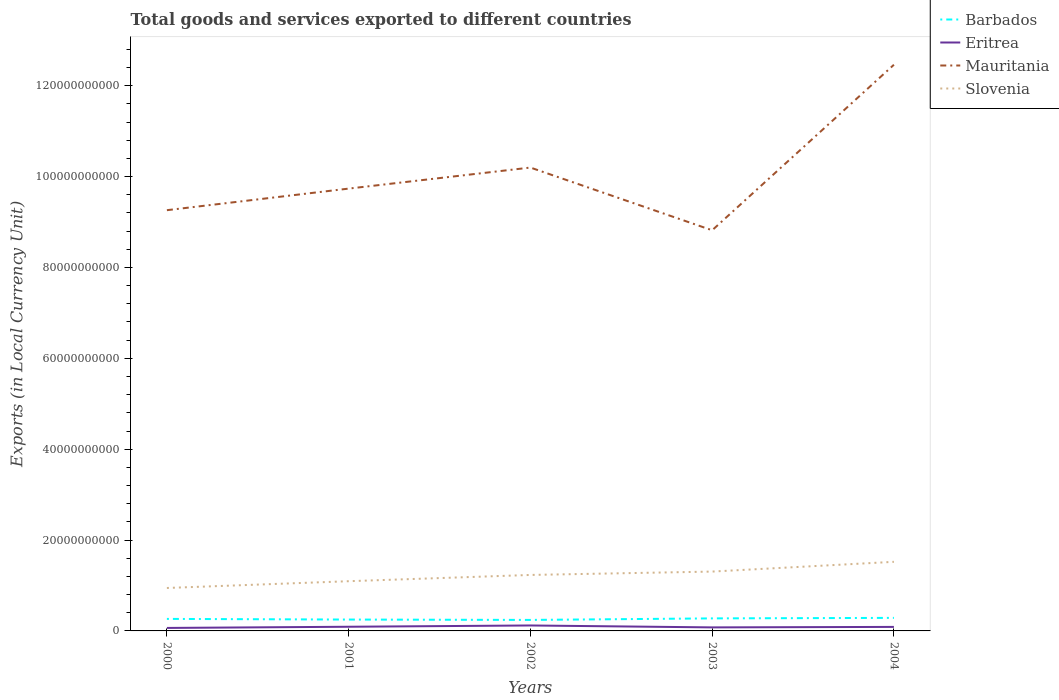Does the line corresponding to Slovenia intersect with the line corresponding to Eritrea?
Keep it short and to the point. No. Across all years, what is the maximum Amount of goods and services exports in Eritrea?
Your response must be concise. 6.57e+08. In which year was the Amount of goods and services exports in Eritrea maximum?
Your response must be concise. 2000. What is the total Amount of goods and services exports in Barbados in the graph?
Keep it short and to the point. -3.69e+08. What is the difference between the highest and the second highest Amount of goods and services exports in Eritrea?
Give a very brief answer. 5.42e+08. What is the difference between two consecutive major ticks on the Y-axis?
Give a very brief answer. 2.00e+1. Are the values on the major ticks of Y-axis written in scientific E-notation?
Provide a short and direct response. No. Does the graph contain any zero values?
Give a very brief answer. No. Does the graph contain grids?
Provide a succinct answer. No. Where does the legend appear in the graph?
Provide a short and direct response. Top right. How many legend labels are there?
Offer a very short reply. 4. What is the title of the graph?
Offer a very short reply. Total goods and services exported to different countries. What is the label or title of the X-axis?
Your response must be concise. Years. What is the label or title of the Y-axis?
Your response must be concise. Exports (in Local Currency Unit). What is the Exports (in Local Currency Unit) in Barbados in 2000?
Offer a terse response. 2.65e+09. What is the Exports (in Local Currency Unit) of Eritrea in 2000?
Make the answer very short. 6.57e+08. What is the Exports (in Local Currency Unit) in Mauritania in 2000?
Your answer should be very brief. 9.26e+1. What is the Exports (in Local Currency Unit) in Slovenia in 2000?
Make the answer very short. 9.45e+09. What is the Exports (in Local Currency Unit) in Barbados in 2001?
Your answer should be very brief. 2.50e+09. What is the Exports (in Local Currency Unit) of Eritrea in 2001?
Ensure brevity in your answer.  9.20e+08. What is the Exports (in Local Currency Unit) of Mauritania in 2001?
Your answer should be very brief. 9.74e+1. What is the Exports (in Local Currency Unit) in Slovenia in 2001?
Your response must be concise. 1.09e+1. What is the Exports (in Local Currency Unit) in Barbados in 2002?
Give a very brief answer. 2.42e+09. What is the Exports (in Local Currency Unit) of Eritrea in 2002?
Provide a short and direct response. 1.20e+09. What is the Exports (in Local Currency Unit) of Mauritania in 2002?
Give a very brief answer. 1.02e+11. What is the Exports (in Local Currency Unit) in Slovenia in 2002?
Provide a short and direct response. 1.23e+1. What is the Exports (in Local Currency Unit) of Barbados in 2003?
Offer a very short reply. 2.76e+09. What is the Exports (in Local Currency Unit) in Eritrea in 2003?
Offer a terse response. 7.78e+08. What is the Exports (in Local Currency Unit) in Mauritania in 2003?
Keep it short and to the point. 8.82e+1. What is the Exports (in Local Currency Unit) in Slovenia in 2003?
Your answer should be compact. 1.31e+1. What is the Exports (in Local Currency Unit) of Barbados in 2004?
Your response must be concise. 2.87e+09. What is the Exports (in Local Currency Unit) of Eritrea in 2004?
Make the answer very short. 8.83e+08. What is the Exports (in Local Currency Unit) of Mauritania in 2004?
Ensure brevity in your answer.  1.25e+11. What is the Exports (in Local Currency Unit) in Slovenia in 2004?
Give a very brief answer. 1.52e+1. Across all years, what is the maximum Exports (in Local Currency Unit) of Barbados?
Give a very brief answer. 2.87e+09. Across all years, what is the maximum Exports (in Local Currency Unit) in Eritrea?
Ensure brevity in your answer.  1.20e+09. Across all years, what is the maximum Exports (in Local Currency Unit) in Mauritania?
Give a very brief answer. 1.25e+11. Across all years, what is the maximum Exports (in Local Currency Unit) of Slovenia?
Make the answer very short. 1.52e+1. Across all years, what is the minimum Exports (in Local Currency Unit) of Barbados?
Your answer should be compact. 2.42e+09. Across all years, what is the minimum Exports (in Local Currency Unit) of Eritrea?
Keep it short and to the point. 6.57e+08. Across all years, what is the minimum Exports (in Local Currency Unit) in Mauritania?
Ensure brevity in your answer.  8.82e+1. Across all years, what is the minimum Exports (in Local Currency Unit) of Slovenia?
Give a very brief answer. 9.45e+09. What is the total Exports (in Local Currency Unit) in Barbados in the graph?
Keep it short and to the point. 1.32e+1. What is the total Exports (in Local Currency Unit) of Eritrea in the graph?
Keep it short and to the point. 4.44e+09. What is the total Exports (in Local Currency Unit) in Mauritania in the graph?
Provide a short and direct response. 5.05e+11. What is the total Exports (in Local Currency Unit) of Slovenia in the graph?
Provide a succinct answer. 6.10e+1. What is the difference between the Exports (in Local Currency Unit) in Barbados in 2000 and that in 2001?
Provide a short and direct response. 1.43e+08. What is the difference between the Exports (in Local Currency Unit) of Eritrea in 2000 and that in 2001?
Offer a very short reply. -2.62e+08. What is the difference between the Exports (in Local Currency Unit) in Mauritania in 2000 and that in 2001?
Provide a short and direct response. -4.75e+09. What is the difference between the Exports (in Local Currency Unit) of Slovenia in 2000 and that in 2001?
Provide a short and direct response. -1.49e+09. What is the difference between the Exports (in Local Currency Unit) in Barbados in 2000 and that in 2002?
Provide a short and direct response. 2.24e+08. What is the difference between the Exports (in Local Currency Unit) of Eritrea in 2000 and that in 2002?
Keep it short and to the point. -5.42e+08. What is the difference between the Exports (in Local Currency Unit) in Mauritania in 2000 and that in 2002?
Provide a succinct answer. -9.38e+09. What is the difference between the Exports (in Local Currency Unit) of Slovenia in 2000 and that in 2002?
Ensure brevity in your answer.  -2.87e+09. What is the difference between the Exports (in Local Currency Unit) in Barbados in 2000 and that in 2003?
Offer a terse response. -1.12e+08. What is the difference between the Exports (in Local Currency Unit) of Eritrea in 2000 and that in 2003?
Make the answer very short. -1.21e+08. What is the difference between the Exports (in Local Currency Unit) of Mauritania in 2000 and that in 2003?
Your response must be concise. 4.42e+09. What is the difference between the Exports (in Local Currency Unit) in Slovenia in 2000 and that in 2003?
Give a very brief answer. -3.61e+09. What is the difference between the Exports (in Local Currency Unit) in Barbados in 2000 and that in 2004?
Your answer should be very brief. -2.26e+08. What is the difference between the Exports (in Local Currency Unit) of Eritrea in 2000 and that in 2004?
Ensure brevity in your answer.  -2.26e+08. What is the difference between the Exports (in Local Currency Unit) of Mauritania in 2000 and that in 2004?
Provide a short and direct response. -3.20e+1. What is the difference between the Exports (in Local Currency Unit) in Slovenia in 2000 and that in 2004?
Give a very brief answer. -5.76e+09. What is the difference between the Exports (in Local Currency Unit) in Barbados in 2001 and that in 2002?
Your answer should be compact. 8.10e+07. What is the difference between the Exports (in Local Currency Unit) of Eritrea in 2001 and that in 2002?
Give a very brief answer. -2.80e+08. What is the difference between the Exports (in Local Currency Unit) of Mauritania in 2001 and that in 2002?
Ensure brevity in your answer.  -4.63e+09. What is the difference between the Exports (in Local Currency Unit) in Slovenia in 2001 and that in 2002?
Your response must be concise. -1.38e+09. What is the difference between the Exports (in Local Currency Unit) in Barbados in 2001 and that in 2003?
Give a very brief answer. -2.55e+08. What is the difference between the Exports (in Local Currency Unit) in Eritrea in 2001 and that in 2003?
Make the answer very short. 1.42e+08. What is the difference between the Exports (in Local Currency Unit) in Mauritania in 2001 and that in 2003?
Your answer should be compact. 9.17e+09. What is the difference between the Exports (in Local Currency Unit) in Slovenia in 2001 and that in 2003?
Give a very brief answer. -2.12e+09. What is the difference between the Exports (in Local Currency Unit) in Barbados in 2001 and that in 2004?
Give a very brief answer. -3.69e+08. What is the difference between the Exports (in Local Currency Unit) in Eritrea in 2001 and that in 2004?
Your answer should be very brief. 3.64e+07. What is the difference between the Exports (in Local Currency Unit) in Mauritania in 2001 and that in 2004?
Your response must be concise. -2.73e+1. What is the difference between the Exports (in Local Currency Unit) of Slovenia in 2001 and that in 2004?
Offer a terse response. -4.27e+09. What is the difference between the Exports (in Local Currency Unit) in Barbados in 2002 and that in 2003?
Offer a very short reply. -3.36e+08. What is the difference between the Exports (in Local Currency Unit) in Eritrea in 2002 and that in 2003?
Keep it short and to the point. 4.21e+08. What is the difference between the Exports (in Local Currency Unit) of Mauritania in 2002 and that in 2003?
Offer a very short reply. 1.38e+1. What is the difference between the Exports (in Local Currency Unit) in Slovenia in 2002 and that in 2003?
Make the answer very short. -7.43e+08. What is the difference between the Exports (in Local Currency Unit) in Barbados in 2002 and that in 2004?
Ensure brevity in your answer.  -4.50e+08. What is the difference between the Exports (in Local Currency Unit) of Eritrea in 2002 and that in 2004?
Keep it short and to the point. 3.16e+08. What is the difference between the Exports (in Local Currency Unit) of Mauritania in 2002 and that in 2004?
Your response must be concise. -2.26e+1. What is the difference between the Exports (in Local Currency Unit) in Slovenia in 2002 and that in 2004?
Your answer should be compact. -2.89e+09. What is the difference between the Exports (in Local Currency Unit) of Barbados in 2003 and that in 2004?
Your answer should be very brief. -1.14e+08. What is the difference between the Exports (in Local Currency Unit) of Eritrea in 2003 and that in 2004?
Your response must be concise. -1.05e+08. What is the difference between the Exports (in Local Currency Unit) of Mauritania in 2003 and that in 2004?
Offer a terse response. -3.64e+1. What is the difference between the Exports (in Local Currency Unit) of Slovenia in 2003 and that in 2004?
Your answer should be compact. -2.15e+09. What is the difference between the Exports (in Local Currency Unit) of Barbados in 2000 and the Exports (in Local Currency Unit) of Eritrea in 2001?
Provide a short and direct response. 1.73e+09. What is the difference between the Exports (in Local Currency Unit) of Barbados in 2000 and the Exports (in Local Currency Unit) of Mauritania in 2001?
Provide a succinct answer. -9.47e+1. What is the difference between the Exports (in Local Currency Unit) in Barbados in 2000 and the Exports (in Local Currency Unit) in Slovenia in 2001?
Offer a very short reply. -8.30e+09. What is the difference between the Exports (in Local Currency Unit) in Eritrea in 2000 and the Exports (in Local Currency Unit) in Mauritania in 2001?
Offer a terse response. -9.67e+1. What is the difference between the Exports (in Local Currency Unit) in Eritrea in 2000 and the Exports (in Local Currency Unit) in Slovenia in 2001?
Your answer should be very brief. -1.03e+1. What is the difference between the Exports (in Local Currency Unit) in Mauritania in 2000 and the Exports (in Local Currency Unit) in Slovenia in 2001?
Offer a very short reply. 8.17e+1. What is the difference between the Exports (in Local Currency Unit) in Barbados in 2000 and the Exports (in Local Currency Unit) in Eritrea in 2002?
Keep it short and to the point. 1.45e+09. What is the difference between the Exports (in Local Currency Unit) in Barbados in 2000 and the Exports (in Local Currency Unit) in Mauritania in 2002?
Offer a very short reply. -9.93e+1. What is the difference between the Exports (in Local Currency Unit) of Barbados in 2000 and the Exports (in Local Currency Unit) of Slovenia in 2002?
Your answer should be very brief. -9.67e+09. What is the difference between the Exports (in Local Currency Unit) in Eritrea in 2000 and the Exports (in Local Currency Unit) in Mauritania in 2002?
Provide a short and direct response. -1.01e+11. What is the difference between the Exports (in Local Currency Unit) in Eritrea in 2000 and the Exports (in Local Currency Unit) in Slovenia in 2002?
Your response must be concise. -1.17e+1. What is the difference between the Exports (in Local Currency Unit) of Mauritania in 2000 and the Exports (in Local Currency Unit) of Slovenia in 2002?
Ensure brevity in your answer.  8.03e+1. What is the difference between the Exports (in Local Currency Unit) of Barbados in 2000 and the Exports (in Local Currency Unit) of Eritrea in 2003?
Provide a succinct answer. 1.87e+09. What is the difference between the Exports (in Local Currency Unit) in Barbados in 2000 and the Exports (in Local Currency Unit) in Mauritania in 2003?
Provide a short and direct response. -8.55e+1. What is the difference between the Exports (in Local Currency Unit) of Barbados in 2000 and the Exports (in Local Currency Unit) of Slovenia in 2003?
Offer a terse response. -1.04e+1. What is the difference between the Exports (in Local Currency Unit) in Eritrea in 2000 and the Exports (in Local Currency Unit) in Mauritania in 2003?
Offer a terse response. -8.75e+1. What is the difference between the Exports (in Local Currency Unit) in Eritrea in 2000 and the Exports (in Local Currency Unit) in Slovenia in 2003?
Make the answer very short. -1.24e+1. What is the difference between the Exports (in Local Currency Unit) of Mauritania in 2000 and the Exports (in Local Currency Unit) of Slovenia in 2003?
Give a very brief answer. 7.95e+1. What is the difference between the Exports (in Local Currency Unit) of Barbados in 2000 and the Exports (in Local Currency Unit) of Eritrea in 2004?
Provide a short and direct response. 1.76e+09. What is the difference between the Exports (in Local Currency Unit) of Barbados in 2000 and the Exports (in Local Currency Unit) of Mauritania in 2004?
Ensure brevity in your answer.  -1.22e+11. What is the difference between the Exports (in Local Currency Unit) of Barbados in 2000 and the Exports (in Local Currency Unit) of Slovenia in 2004?
Provide a short and direct response. -1.26e+1. What is the difference between the Exports (in Local Currency Unit) of Eritrea in 2000 and the Exports (in Local Currency Unit) of Mauritania in 2004?
Keep it short and to the point. -1.24e+11. What is the difference between the Exports (in Local Currency Unit) in Eritrea in 2000 and the Exports (in Local Currency Unit) in Slovenia in 2004?
Keep it short and to the point. -1.46e+1. What is the difference between the Exports (in Local Currency Unit) in Mauritania in 2000 and the Exports (in Local Currency Unit) in Slovenia in 2004?
Your answer should be compact. 7.74e+1. What is the difference between the Exports (in Local Currency Unit) in Barbados in 2001 and the Exports (in Local Currency Unit) in Eritrea in 2002?
Provide a succinct answer. 1.30e+09. What is the difference between the Exports (in Local Currency Unit) in Barbados in 2001 and the Exports (in Local Currency Unit) in Mauritania in 2002?
Your answer should be compact. -9.95e+1. What is the difference between the Exports (in Local Currency Unit) in Barbados in 2001 and the Exports (in Local Currency Unit) in Slovenia in 2002?
Make the answer very short. -9.82e+09. What is the difference between the Exports (in Local Currency Unit) in Eritrea in 2001 and the Exports (in Local Currency Unit) in Mauritania in 2002?
Make the answer very short. -1.01e+11. What is the difference between the Exports (in Local Currency Unit) of Eritrea in 2001 and the Exports (in Local Currency Unit) of Slovenia in 2002?
Your response must be concise. -1.14e+1. What is the difference between the Exports (in Local Currency Unit) of Mauritania in 2001 and the Exports (in Local Currency Unit) of Slovenia in 2002?
Provide a short and direct response. 8.50e+1. What is the difference between the Exports (in Local Currency Unit) of Barbados in 2001 and the Exports (in Local Currency Unit) of Eritrea in 2003?
Your response must be concise. 1.72e+09. What is the difference between the Exports (in Local Currency Unit) of Barbados in 2001 and the Exports (in Local Currency Unit) of Mauritania in 2003?
Provide a short and direct response. -8.57e+1. What is the difference between the Exports (in Local Currency Unit) in Barbados in 2001 and the Exports (in Local Currency Unit) in Slovenia in 2003?
Offer a terse response. -1.06e+1. What is the difference between the Exports (in Local Currency Unit) in Eritrea in 2001 and the Exports (in Local Currency Unit) in Mauritania in 2003?
Provide a succinct answer. -8.73e+1. What is the difference between the Exports (in Local Currency Unit) of Eritrea in 2001 and the Exports (in Local Currency Unit) of Slovenia in 2003?
Your answer should be very brief. -1.21e+1. What is the difference between the Exports (in Local Currency Unit) in Mauritania in 2001 and the Exports (in Local Currency Unit) in Slovenia in 2003?
Ensure brevity in your answer.  8.43e+1. What is the difference between the Exports (in Local Currency Unit) of Barbados in 2001 and the Exports (in Local Currency Unit) of Eritrea in 2004?
Give a very brief answer. 1.62e+09. What is the difference between the Exports (in Local Currency Unit) in Barbados in 2001 and the Exports (in Local Currency Unit) in Mauritania in 2004?
Make the answer very short. -1.22e+11. What is the difference between the Exports (in Local Currency Unit) of Barbados in 2001 and the Exports (in Local Currency Unit) of Slovenia in 2004?
Make the answer very short. -1.27e+1. What is the difference between the Exports (in Local Currency Unit) of Eritrea in 2001 and the Exports (in Local Currency Unit) of Mauritania in 2004?
Offer a terse response. -1.24e+11. What is the difference between the Exports (in Local Currency Unit) of Eritrea in 2001 and the Exports (in Local Currency Unit) of Slovenia in 2004?
Give a very brief answer. -1.43e+1. What is the difference between the Exports (in Local Currency Unit) in Mauritania in 2001 and the Exports (in Local Currency Unit) in Slovenia in 2004?
Provide a succinct answer. 8.21e+1. What is the difference between the Exports (in Local Currency Unit) in Barbados in 2002 and the Exports (in Local Currency Unit) in Eritrea in 2003?
Offer a very short reply. 1.64e+09. What is the difference between the Exports (in Local Currency Unit) of Barbados in 2002 and the Exports (in Local Currency Unit) of Mauritania in 2003?
Your answer should be compact. -8.58e+1. What is the difference between the Exports (in Local Currency Unit) in Barbados in 2002 and the Exports (in Local Currency Unit) in Slovenia in 2003?
Your answer should be compact. -1.06e+1. What is the difference between the Exports (in Local Currency Unit) of Eritrea in 2002 and the Exports (in Local Currency Unit) of Mauritania in 2003?
Your answer should be compact. -8.70e+1. What is the difference between the Exports (in Local Currency Unit) in Eritrea in 2002 and the Exports (in Local Currency Unit) in Slovenia in 2003?
Make the answer very short. -1.19e+1. What is the difference between the Exports (in Local Currency Unit) in Mauritania in 2002 and the Exports (in Local Currency Unit) in Slovenia in 2003?
Offer a very short reply. 8.89e+1. What is the difference between the Exports (in Local Currency Unit) in Barbados in 2002 and the Exports (in Local Currency Unit) in Eritrea in 2004?
Your answer should be very brief. 1.54e+09. What is the difference between the Exports (in Local Currency Unit) in Barbados in 2002 and the Exports (in Local Currency Unit) in Mauritania in 2004?
Provide a succinct answer. -1.22e+11. What is the difference between the Exports (in Local Currency Unit) of Barbados in 2002 and the Exports (in Local Currency Unit) of Slovenia in 2004?
Offer a terse response. -1.28e+1. What is the difference between the Exports (in Local Currency Unit) in Eritrea in 2002 and the Exports (in Local Currency Unit) in Mauritania in 2004?
Provide a succinct answer. -1.23e+11. What is the difference between the Exports (in Local Currency Unit) in Eritrea in 2002 and the Exports (in Local Currency Unit) in Slovenia in 2004?
Your response must be concise. -1.40e+1. What is the difference between the Exports (in Local Currency Unit) of Mauritania in 2002 and the Exports (in Local Currency Unit) of Slovenia in 2004?
Offer a terse response. 8.68e+1. What is the difference between the Exports (in Local Currency Unit) of Barbados in 2003 and the Exports (in Local Currency Unit) of Eritrea in 2004?
Your answer should be very brief. 1.87e+09. What is the difference between the Exports (in Local Currency Unit) of Barbados in 2003 and the Exports (in Local Currency Unit) of Mauritania in 2004?
Ensure brevity in your answer.  -1.22e+11. What is the difference between the Exports (in Local Currency Unit) of Barbados in 2003 and the Exports (in Local Currency Unit) of Slovenia in 2004?
Give a very brief answer. -1.25e+1. What is the difference between the Exports (in Local Currency Unit) of Eritrea in 2003 and the Exports (in Local Currency Unit) of Mauritania in 2004?
Your response must be concise. -1.24e+11. What is the difference between the Exports (in Local Currency Unit) of Eritrea in 2003 and the Exports (in Local Currency Unit) of Slovenia in 2004?
Your response must be concise. -1.44e+1. What is the difference between the Exports (in Local Currency Unit) in Mauritania in 2003 and the Exports (in Local Currency Unit) in Slovenia in 2004?
Give a very brief answer. 7.30e+1. What is the average Exports (in Local Currency Unit) of Barbados per year?
Keep it short and to the point. 2.64e+09. What is the average Exports (in Local Currency Unit) in Eritrea per year?
Give a very brief answer. 8.88e+08. What is the average Exports (in Local Currency Unit) of Mauritania per year?
Your answer should be compact. 1.01e+11. What is the average Exports (in Local Currency Unit) of Slovenia per year?
Provide a succinct answer. 1.22e+1. In the year 2000, what is the difference between the Exports (in Local Currency Unit) of Barbados and Exports (in Local Currency Unit) of Eritrea?
Offer a terse response. 1.99e+09. In the year 2000, what is the difference between the Exports (in Local Currency Unit) in Barbados and Exports (in Local Currency Unit) in Mauritania?
Offer a very short reply. -9.00e+1. In the year 2000, what is the difference between the Exports (in Local Currency Unit) in Barbados and Exports (in Local Currency Unit) in Slovenia?
Make the answer very short. -6.81e+09. In the year 2000, what is the difference between the Exports (in Local Currency Unit) of Eritrea and Exports (in Local Currency Unit) of Mauritania?
Your answer should be very brief. -9.19e+1. In the year 2000, what is the difference between the Exports (in Local Currency Unit) in Eritrea and Exports (in Local Currency Unit) in Slovenia?
Keep it short and to the point. -8.79e+09. In the year 2000, what is the difference between the Exports (in Local Currency Unit) in Mauritania and Exports (in Local Currency Unit) in Slovenia?
Make the answer very short. 8.32e+1. In the year 2001, what is the difference between the Exports (in Local Currency Unit) of Barbados and Exports (in Local Currency Unit) of Eritrea?
Keep it short and to the point. 1.58e+09. In the year 2001, what is the difference between the Exports (in Local Currency Unit) in Barbados and Exports (in Local Currency Unit) in Mauritania?
Your answer should be compact. -9.49e+1. In the year 2001, what is the difference between the Exports (in Local Currency Unit) of Barbados and Exports (in Local Currency Unit) of Slovenia?
Keep it short and to the point. -8.44e+09. In the year 2001, what is the difference between the Exports (in Local Currency Unit) in Eritrea and Exports (in Local Currency Unit) in Mauritania?
Provide a succinct answer. -9.64e+1. In the year 2001, what is the difference between the Exports (in Local Currency Unit) in Eritrea and Exports (in Local Currency Unit) in Slovenia?
Make the answer very short. -1.00e+1. In the year 2001, what is the difference between the Exports (in Local Currency Unit) of Mauritania and Exports (in Local Currency Unit) of Slovenia?
Offer a terse response. 8.64e+1. In the year 2002, what is the difference between the Exports (in Local Currency Unit) of Barbados and Exports (in Local Currency Unit) of Eritrea?
Your answer should be compact. 1.22e+09. In the year 2002, what is the difference between the Exports (in Local Currency Unit) of Barbados and Exports (in Local Currency Unit) of Mauritania?
Make the answer very short. -9.96e+1. In the year 2002, what is the difference between the Exports (in Local Currency Unit) in Barbados and Exports (in Local Currency Unit) in Slovenia?
Give a very brief answer. -9.90e+09. In the year 2002, what is the difference between the Exports (in Local Currency Unit) of Eritrea and Exports (in Local Currency Unit) of Mauritania?
Your answer should be compact. -1.01e+11. In the year 2002, what is the difference between the Exports (in Local Currency Unit) in Eritrea and Exports (in Local Currency Unit) in Slovenia?
Offer a very short reply. -1.11e+1. In the year 2002, what is the difference between the Exports (in Local Currency Unit) in Mauritania and Exports (in Local Currency Unit) in Slovenia?
Ensure brevity in your answer.  8.97e+1. In the year 2003, what is the difference between the Exports (in Local Currency Unit) of Barbados and Exports (in Local Currency Unit) of Eritrea?
Make the answer very short. 1.98e+09. In the year 2003, what is the difference between the Exports (in Local Currency Unit) of Barbados and Exports (in Local Currency Unit) of Mauritania?
Provide a short and direct response. -8.54e+1. In the year 2003, what is the difference between the Exports (in Local Currency Unit) in Barbados and Exports (in Local Currency Unit) in Slovenia?
Keep it short and to the point. -1.03e+1. In the year 2003, what is the difference between the Exports (in Local Currency Unit) in Eritrea and Exports (in Local Currency Unit) in Mauritania?
Make the answer very short. -8.74e+1. In the year 2003, what is the difference between the Exports (in Local Currency Unit) in Eritrea and Exports (in Local Currency Unit) in Slovenia?
Offer a very short reply. -1.23e+1. In the year 2003, what is the difference between the Exports (in Local Currency Unit) in Mauritania and Exports (in Local Currency Unit) in Slovenia?
Keep it short and to the point. 7.51e+1. In the year 2004, what is the difference between the Exports (in Local Currency Unit) in Barbados and Exports (in Local Currency Unit) in Eritrea?
Keep it short and to the point. 1.99e+09. In the year 2004, what is the difference between the Exports (in Local Currency Unit) in Barbados and Exports (in Local Currency Unit) in Mauritania?
Your response must be concise. -1.22e+11. In the year 2004, what is the difference between the Exports (in Local Currency Unit) in Barbados and Exports (in Local Currency Unit) in Slovenia?
Provide a short and direct response. -1.23e+1. In the year 2004, what is the difference between the Exports (in Local Currency Unit) of Eritrea and Exports (in Local Currency Unit) of Mauritania?
Your response must be concise. -1.24e+11. In the year 2004, what is the difference between the Exports (in Local Currency Unit) of Eritrea and Exports (in Local Currency Unit) of Slovenia?
Your answer should be compact. -1.43e+1. In the year 2004, what is the difference between the Exports (in Local Currency Unit) of Mauritania and Exports (in Local Currency Unit) of Slovenia?
Keep it short and to the point. 1.09e+11. What is the ratio of the Exports (in Local Currency Unit) in Barbados in 2000 to that in 2001?
Provide a short and direct response. 1.06. What is the ratio of the Exports (in Local Currency Unit) of Eritrea in 2000 to that in 2001?
Provide a succinct answer. 0.71. What is the ratio of the Exports (in Local Currency Unit) in Mauritania in 2000 to that in 2001?
Your answer should be very brief. 0.95. What is the ratio of the Exports (in Local Currency Unit) in Slovenia in 2000 to that in 2001?
Your answer should be compact. 0.86. What is the ratio of the Exports (in Local Currency Unit) in Barbados in 2000 to that in 2002?
Your answer should be very brief. 1.09. What is the ratio of the Exports (in Local Currency Unit) in Eritrea in 2000 to that in 2002?
Offer a very short reply. 0.55. What is the ratio of the Exports (in Local Currency Unit) of Mauritania in 2000 to that in 2002?
Ensure brevity in your answer.  0.91. What is the ratio of the Exports (in Local Currency Unit) in Slovenia in 2000 to that in 2002?
Provide a succinct answer. 0.77. What is the ratio of the Exports (in Local Currency Unit) in Barbados in 2000 to that in 2003?
Make the answer very short. 0.96. What is the ratio of the Exports (in Local Currency Unit) of Eritrea in 2000 to that in 2003?
Offer a terse response. 0.84. What is the ratio of the Exports (in Local Currency Unit) in Mauritania in 2000 to that in 2003?
Offer a very short reply. 1.05. What is the ratio of the Exports (in Local Currency Unit) in Slovenia in 2000 to that in 2003?
Offer a terse response. 0.72. What is the ratio of the Exports (in Local Currency Unit) of Barbados in 2000 to that in 2004?
Your answer should be very brief. 0.92. What is the ratio of the Exports (in Local Currency Unit) in Eritrea in 2000 to that in 2004?
Your answer should be compact. 0.74. What is the ratio of the Exports (in Local Currency Unit) of Mauritania in 2000 to that in 2004?
Provide a short and direct response. 0.74. What is the ratio of the Exports (in Local Currency Unit) of Slovenia in 2000 to that in 2004?
Your answer should be compact. 0.62. What is the ratio of the Exports (in Local Currency Unit) of Barbados in 2001 to that in 2002?
Your response must be concise. 1.03. What is the ratio of the Exports (in Local Currency Unit) of Eritrea in 2001 to that in 2002?
Give a very brief answer. 0.77. What is the ratio of the Exports (in Local Currency Unit) in Mauritania in 2001 to that in 2002?
Make the answer very short. 0.95. What is the ratio of the Exports (in Local Currency Unit) of Slovenia in 2001 to that in 2002?
Your answer should be very brief. 0.89. What is the ratio of the Exports (in Local Currency Unit) of Barbados in 2001 to that in 2003?
Make the answer very short. 0.91. What is the ratio of the Exports (in Local Currency Unit) of Eritrea in 2001 to that in 2003?
Your answer should be very brief. 1.18. What is the ratio of the Exports (in Local Currency Unit) of Mauritania in 2001 to that in 2003?
Ensure brevity in your answer.  1.1. What is the ratio of the Exports (in Local Currency Unit) in Slovenia in 2001 to that in 2003?
Your answer should be very brief. 0.84. What is the ratio of the Exports (in Local Currency Unit) of Barbados in 2001 to that in 2004?
Your response must be concise. 0.87. What is the ratio of the Exports (in Local Currency Unit) of Eritrea in 2001 to that in 2004?
Offer a terse response. 1.04. What is the ratio of the Exports (in Local Currency Unit) of Mauritania in 2001 to that in 2004?
Provide a succinct answer. 0.78. What is the ratio of the Exports (in Local Currency Unit) of Slovenia in 2001 to that in 2004?
Provide a succinct answer. 0.72. What is the ratio of the Exports (in Local Currency Unit) of Barbados in 2002 to that in 2003?
Make the answer very short. 0.88. What is the ratio of the Exports (in Local Currency Unit) in Eritrea in 2002 to that in 2003?
Offer a very short reply. 1.54. What is the ratio of the Exports (in Local Currency Unit) of Mauritania in 2002 to that in 2003?
Your answer should be compact. 1.16. What is the ratio of the Exports (in Local Currency Unit) of Slovenia in 2002 to that in 2003?
Provide a short and direct response. 0.94. What is the ratio of the Exports (in Local Currency Unit) of Barbados in 2002 to that in 2004?
Give a very brief answer. 0.84. What is the ratio of the Exports (in Local Currency Unit) in Eritrea in 2002 to that in 2004?
Keep it short and to the point. 1.36. What is the ratio of the Exports (in Local Currency Unit) of Mauritania in 2002 to that in 2004?
Provide a short and direct response. 0.82. What is the ratio of the Exports (in Local Currency Unit) in Slovenia in 2002 to that in 2004?
Provide a succinct answer. 0.81. What is the ratio of the Exports (in Local Currency Unit) in Barbados in 2003 to that in 2004?
Your answer should be compact. 0.96. What is the ratio of the Exports (in Local Currency Unit) of Eritrea in 2003 to that in 2004?
Keep it short and to the point. 0.88. What is the ratio of the Exports (in Local Currency Unit) of Mauritania in 2003 to that in 2004?
Provide a succinct answer. 0.71. What is the ratio of the Exports (in Local Currency Unit) of Slovenia in 2003 to that in 2004?
Provide a succinct answer. 0.86. What is the difference between the highest and the second highest Exports (in Local Currency Unit) of Barbados?
Offer a terse response. 1.14e+08. What is the difference between the highest and the second highest Exports (in Local Currency Unit) in Eritrea?
Ensure brevity in your answer.  2.80e+08. What is the difference between the highest and the second highest Exports (in Local Currency Unit) of Mauritania?
Make the answer very short. 2.26e+1. What is the difference between the highest and the second highest Exports (in Local Currency Unit) in Slovenia?
Offer a terse response. 2.15e+09. What is the difference between the highest and the lowest Exports (in Local Currency Unit) in Barbados?
Your answer should be very brief. 4.50e+08. What is the difference between the highest and the lowest Exports (in Local Currency Unit) in Eritrea?
Offer a very short reply. 5.42e+08. What is the difference between the highest and the lowest Exports (in Local Currency Unit) in Mauritania?
Your answer should be very brief. 3.64e+1. What is the difference between the highest and the lowest Exports (in Local Currency Unit) in Slovenia?
Offer a terse response. 5.76e+09. 